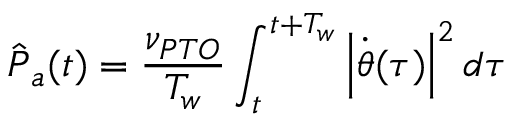Convert formula to latex. <formula><loc_0><loc_0><loc_500><loc_500>\hat { P } _ { a } ( t ) = \frac { \nu _ { P T O } } { T _ { w } } \int _ { t } ^ { t + T _ { w } } \left | \dot { \theta } ( \tau ) \right | ^ { 2 } d \tau</formula> 